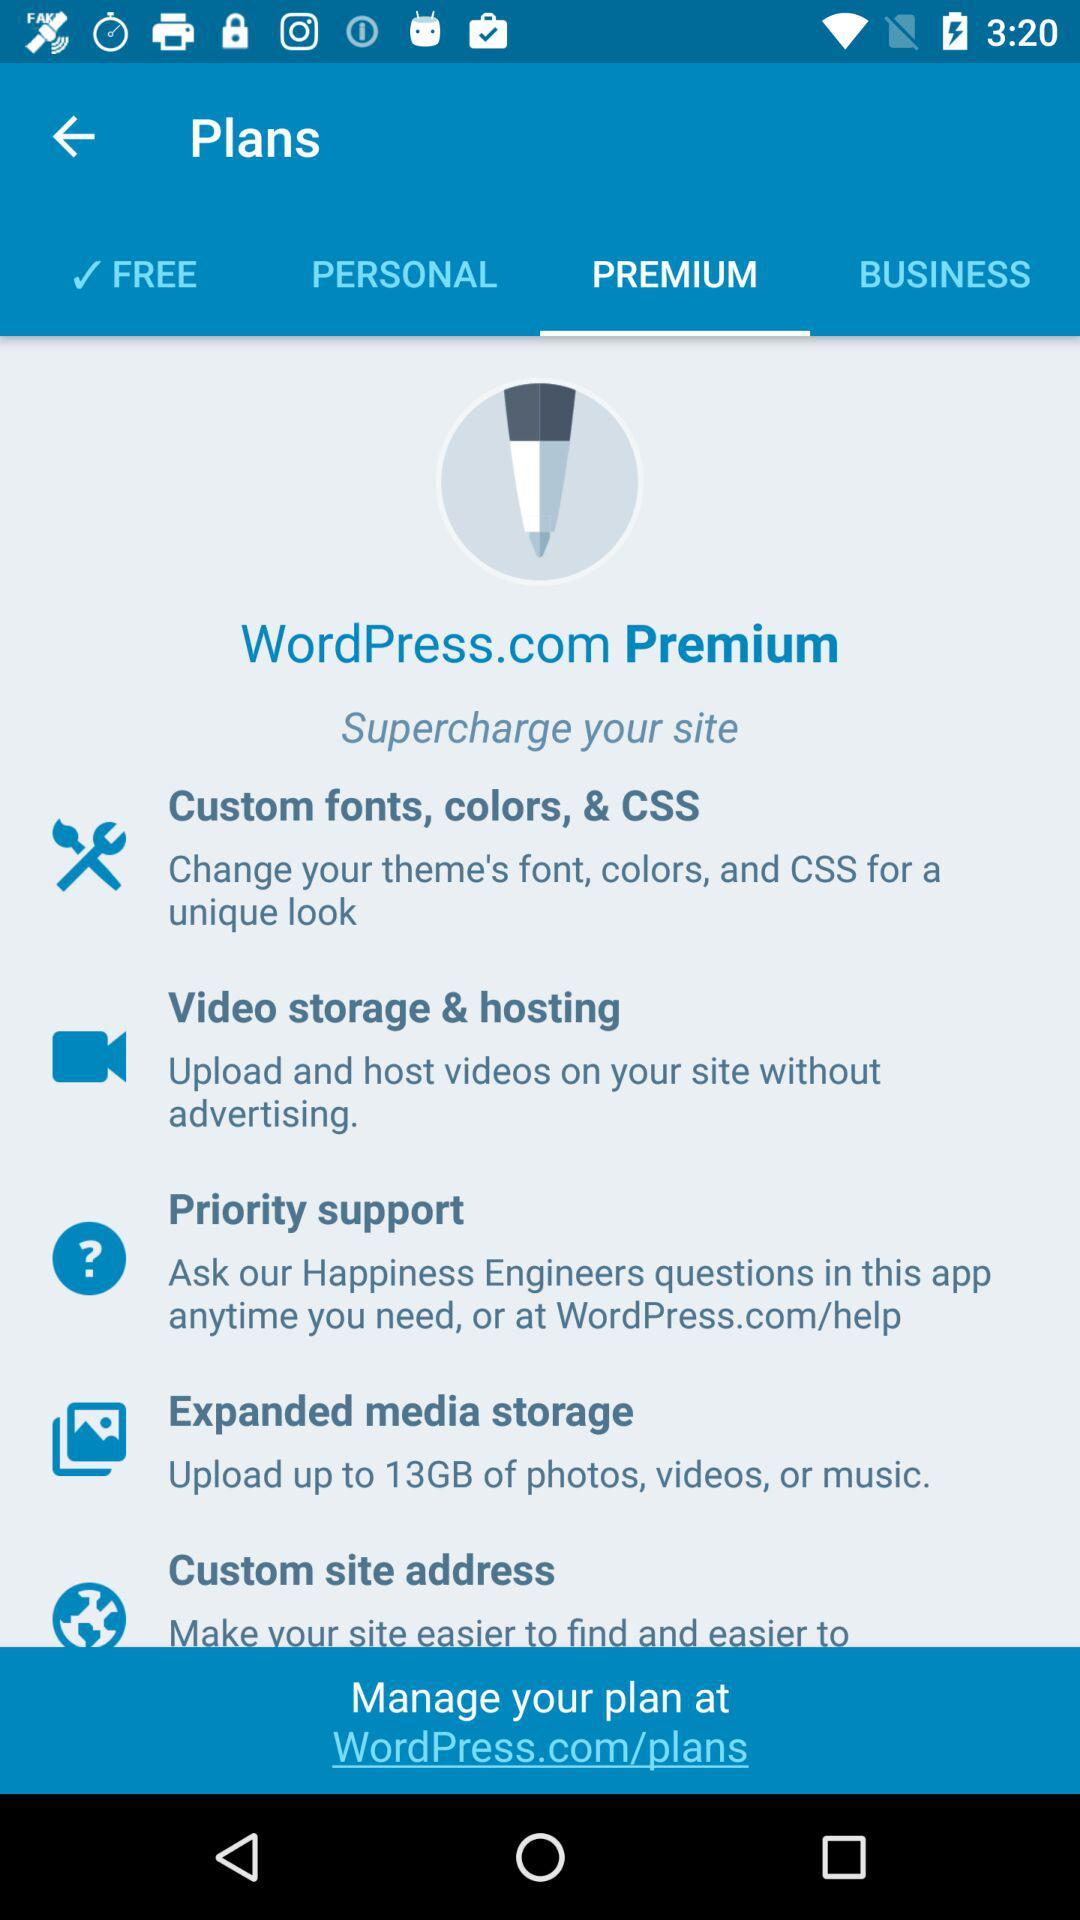On what website can we manage our plans? We can manage our plans on WorldPress.com/plans. 